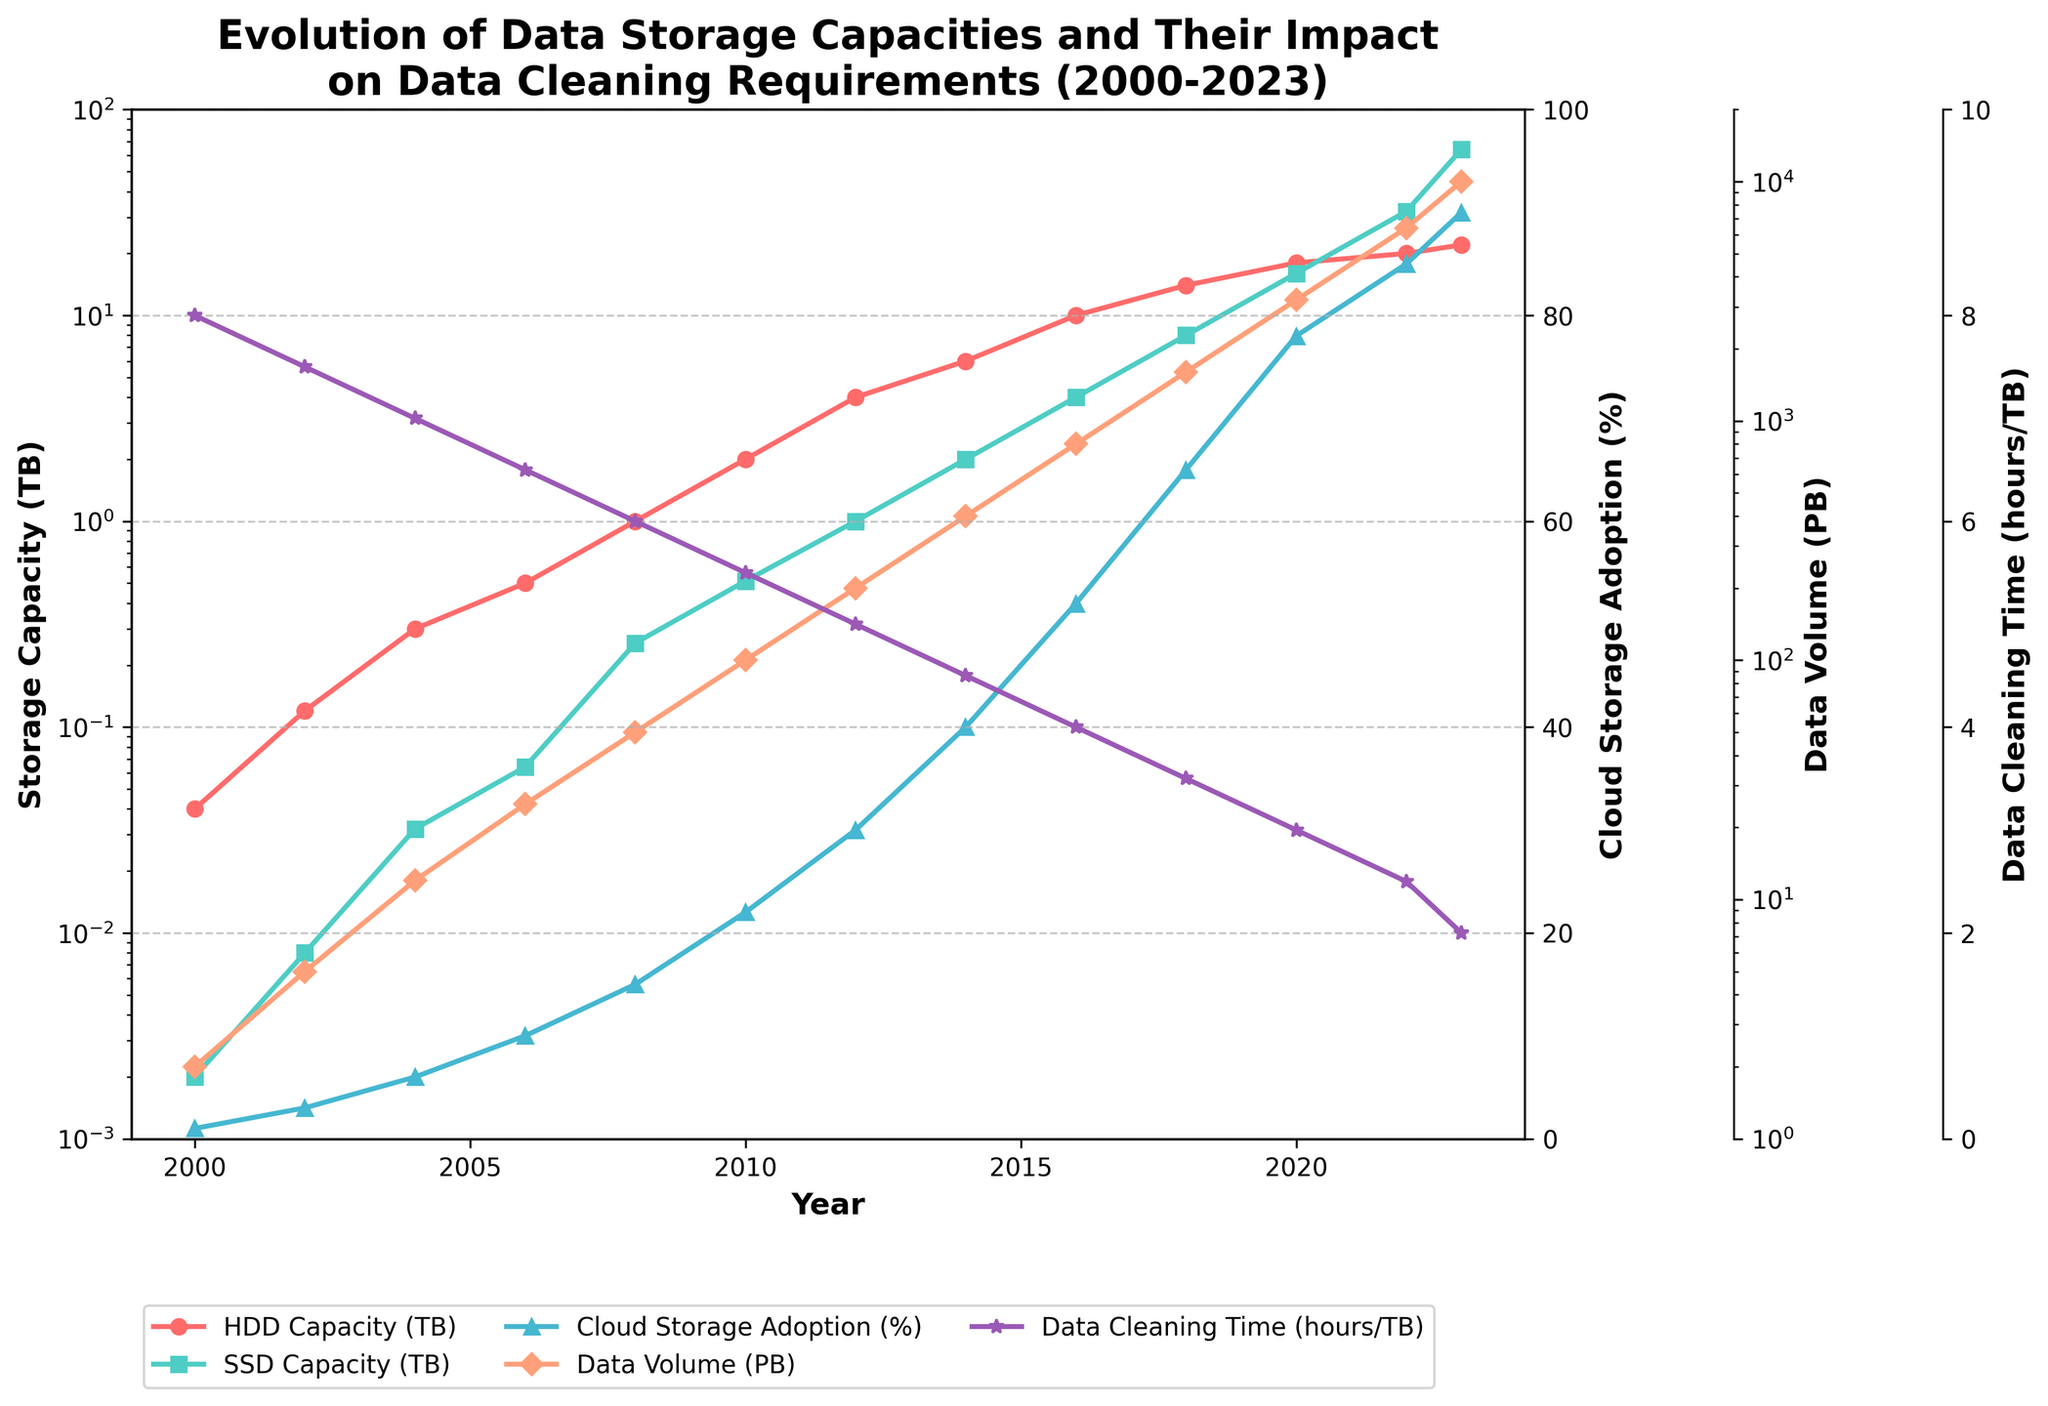How does the HDD capacity in 2022 compare to that in 2006? The HDD capacity in 2022 is 20 TB while in 2006 it was 0.5 TB. This shows that HDD capacity in 2022 is significantly higher than in 2006.
Answer: 20 TB is much greater than 0.5 TB Which year saw the largest increase in cloud storage adoption percentage (from previous year)? In order to determine this, we can look at the adjacent years and calculate the increase. From 2016 to 2018, cloud storage adoption increased from 52% to 65%, which is an increase of 13%. This is the largest increase within the given period.
Answer: From 2016 to 2018 What is the trend of SSD capacity over the years? SSD capacity has increased exponentially from 0.002 TB in 2000 to 64 TB in 2023. This indicates a significant upward trend over the years.
Answer: Upward exponential trend How does the data cleaning time per TB change as data volume increases? As data volume increases over the years from 2 PB in 2000 to 10,000 PB in 2023, the data cleaning time per TB decreases from 8 hours to 2 hours. This inverse relationship indicates improvements in data cleaning efficiency.
Answer: Decreases In which year did the HDD and SSD capacities first equal each other? In 2022, both HDD capacity is 20 TB and SSD capacity is 32 TB. Going back further, in 2018, HDD was 14TB while SSD was 8TB. So, looking at the trend, they first became close (equal or exceeding) in 2020, but not exactly equal.
Answer: Never exactly equal but closest in 2020 What was the approximate data volume when cloud storage adoption was around 65%? By referring to the year 2018 when the cloud storage adoption percentage was 65%, the data volume was approximately 1600 PB.
Answer: 1600 PB Was there a year when HDD capacity was greater than SSD capacity by an order of magnitude? Checking the years, in 2016, HDD capacity was 10 TB while SSD capacity was 4 TB. A previous year is 2012 where HDD capacity was 4 TB while SSD is 1 TB. In 2008, HDD is 1 TB, SSD is 0.256: the ratio is 1: not exactly an order of magnitude. So it should be before 2008; in 2000, HDD was 0.04 TB and SSD was 0.002 TB, an order-of-magnitude difference.
Answer: 2010 or earlier What is the relationship between cloud storage adoption and HDD capacity over the years? As cloud storage adoption increases from 1% in 2000 to 90% in 2023, HDD capacity also increases from 0.04 TB to 22 TB. Both metrics show an upward trend over time, though detailed correlation analysis is implied.
Answer: Both increase In which year did data cleaning time reach half of what it was in 2000? Data cleaning time in 2000 was 8 hours/TB. It reached half, i.e., 4 hours/TB in 2016.
Answer: 2016 